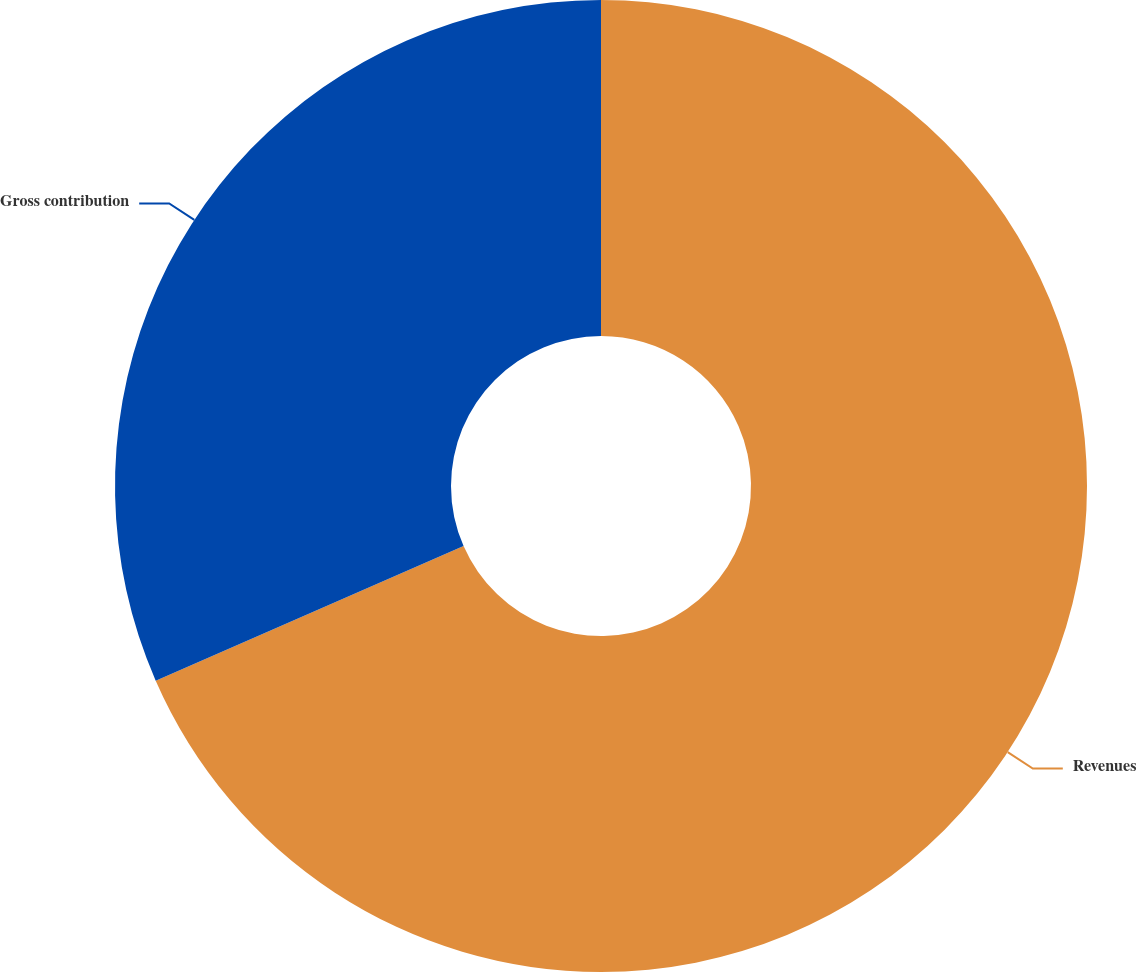Convert chart. <chart><loc_0><loc_0><loc_500><loc_500><pie_chart><fcel>Revenues<fcel>Gross contribution<nl><fcel>68.44%<fcel>31.56%<nl></chart> 